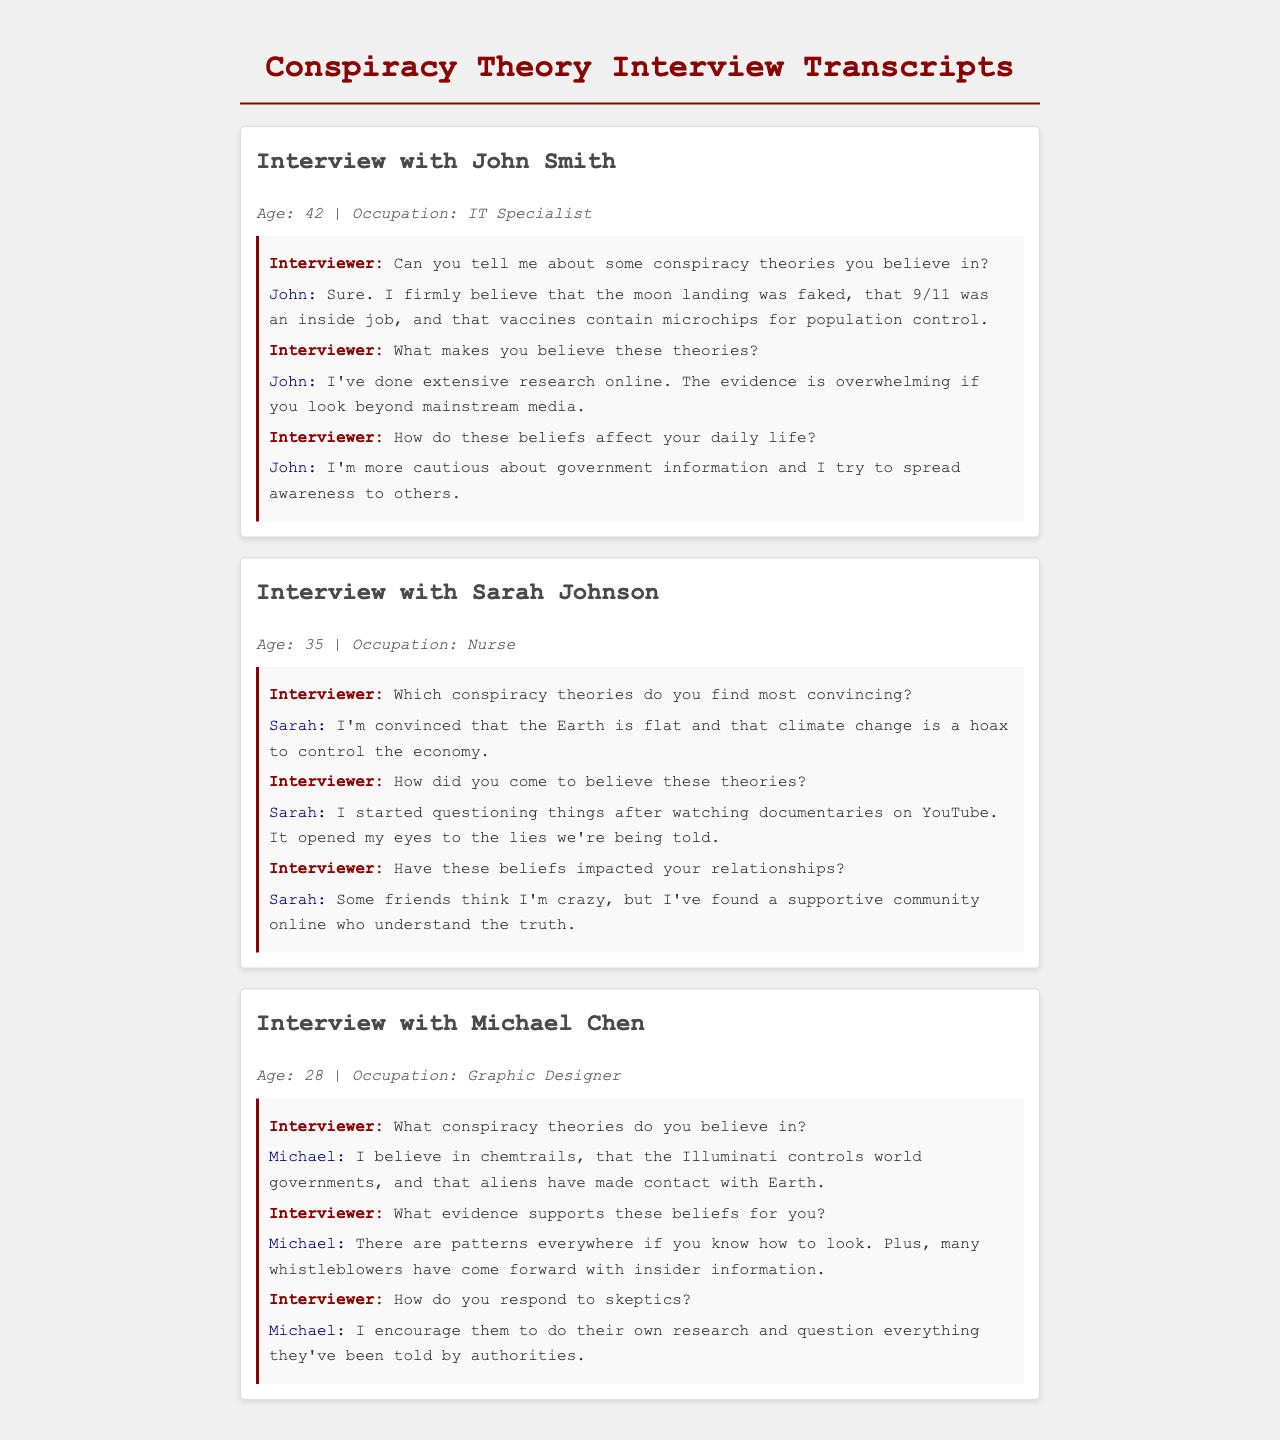What is the name of the first interviewee? The name of the first interviewee is mentioned in the title of the interview section.
Answer: John Smith How many conspiracy theories does Sarah believe in? Sarah mentions two conspiracy theories she believes in during her interview.
Answer: Two What is Michael's occupation? The occupation of Michael is provided in the metadata section of his interview.
Answer: Graphic Designer What conspiracy theory does John mention related to vaccines? John specifically states a belief regarding vaccines during his interview.
Answer: Microchips for population control How did Sarah come to believe in conspiracy theories? Sarah explains the source of her beliefs in documentaries she watched.
Answer: YouTube documentaries What age is Michael Chen? Michael's age is specified in the metadata of his interview.
Answer: 28 